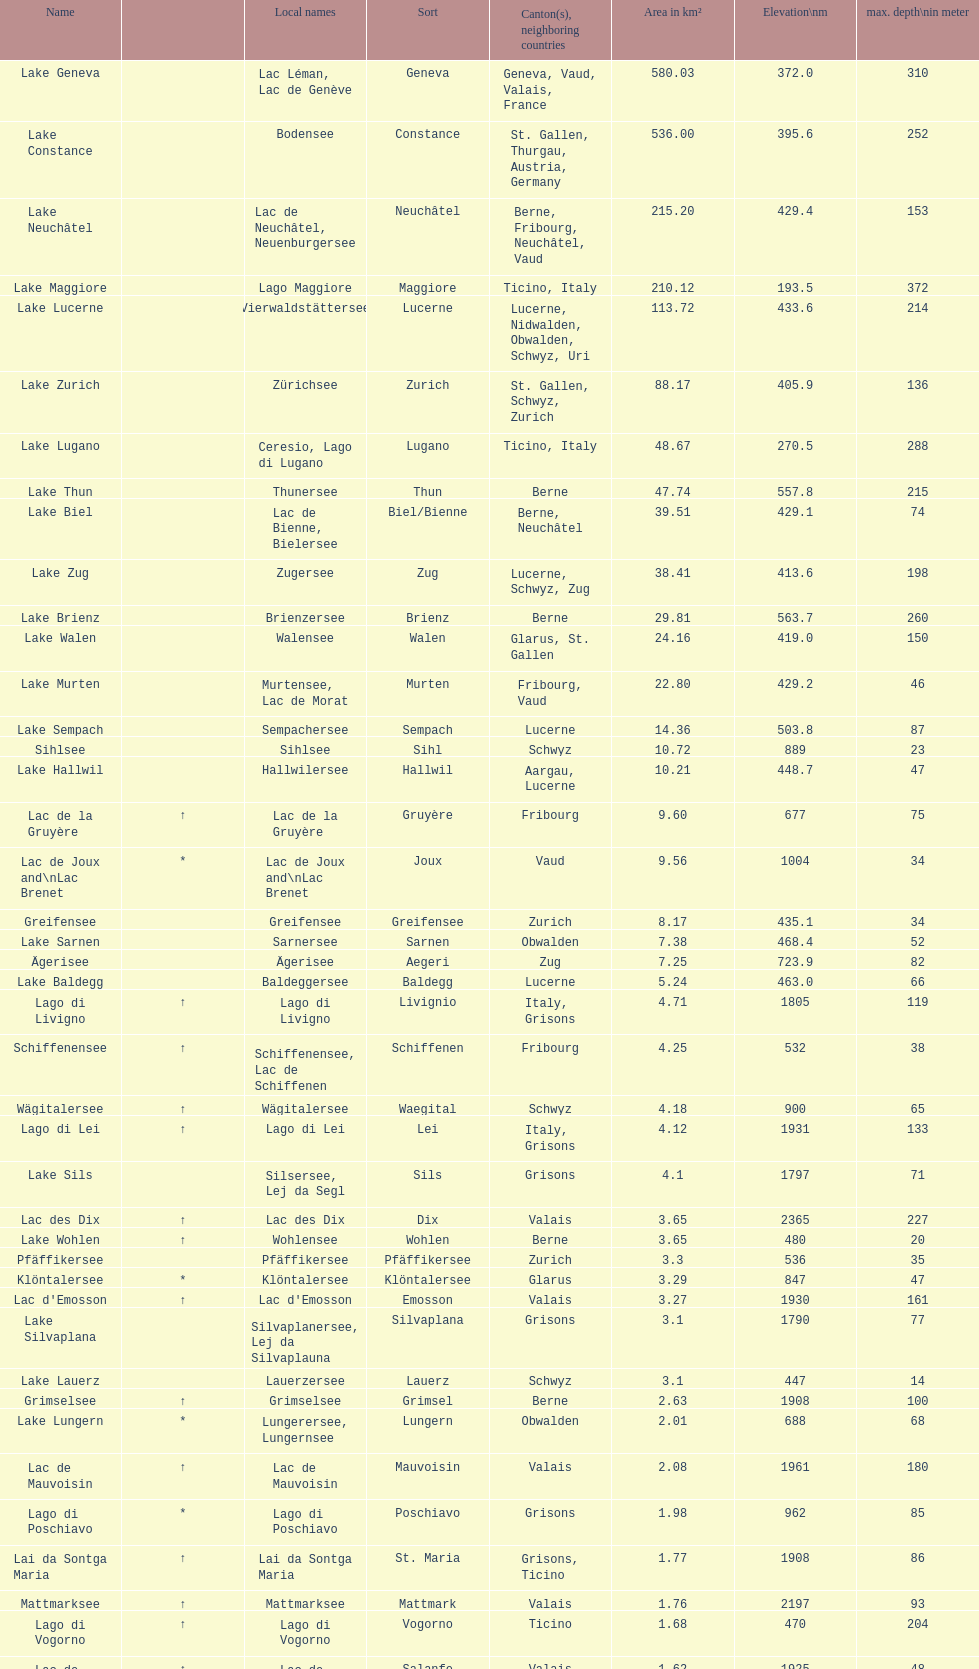Which lake is situated at the highest altitude? Lac des Dix. Can you parse all the data within this table? {'header': ['Name', '', 'Local names', 'Sort', 'Canton(s), neighboring countries', 'Area in km²', 'Elevation\\nm', 'max. depth\\nin meter'], 'rows': [['Lake Geneva', '', 'Lac Léman, Lac de Genève', 'Geneva', 'Geneva, Vaud, Valais, France', '580.03', '372.0', '310'], ['Lake Constance', '', 'Bodensee', 'Constance', 'St. Gallen, Thurgau, Austria, Germany', '536.00', '395.6', '252'], ['Lake Neuchâtel', '', 'Lac de Neuchâtel, Neuenburgersee', 'Neuchâtel', 'Berne, Fribourg, Neuchâtel, Vaud', '215.20', '429.4', '153'], ['Lake Maggiore', '', 'Lago Maggiore', 'Maggiore', 'Ticino, Italy', '210.12', '193.5', '372'], ['Lake Lucerne', '', 'Vierwaldstättersee', 'Lucerne', 'Lucerne, Nidwalden, Obwalden, Schwyz, Uri', '113.72', '433.6', '214'], ['Lake Zurich', '', 'Zürichsee', 'Zurich', 'St. Gallen, Schwyz, Zurich', '88.17', '405.9', '136'], ['Lake Lugano', '', 'Ceresio, Lago di Lugano', 'Lugano', 'Ticino, Italy', '48.67', '270.5', '288'], ['Lake Thun', '', 'Thunersee', 'Thun', 'Berne', '47.74', '557.8', '215'], ['Lake Biel', '', 'Lac de Bienne, Bielersee', 'Biel/Bienne', 'Berne, Neuchâtel', '39.51', '429.1', '74'], ['Lake Zug', '', 'Zugersee', 'Zug', 'Lucerne, Schwyz, Zug', '38.41', '413.6', '198'], ['Lake Brienz', '', 'Brienzersee', 'Brienz', 'Berne', '29.81', '563.7', '260'], ['Lake Walen', '', 'Walensee', 'Walen', 'Glarus, St. Gallen', '24.16', '419.0', '150'], ['Lake Murten', '', 'Murtensee, Lac de Morat', 'Murten', 'Fribourg, Vaud', '22.80', '429.2', '46'], ['Lake Sempach', '', 'Sempachersee', 'Sempach', 'Lucerne', '14.36', '503.8', '87'], ['Sihlsee', '', 'Sihlsee', 'Sihl', 'Schwyz', '10.72', '889', '23'], ['Lake Hallwil', '', 'Hallwilersee', 'Hallwil', 'Aargau, Lucerne', '10.21', '448.7', '47'], ['Lac de la Gruyère', '↑', 'Lac de la Gruyère', 'Gruyère', 'Fribourg', '9.60', '677', '75'], ['Lac de Joux and\\nLac Brenet', '*', 'Lac de Joux and\\nLac Brenet', 'Joux', 'Vaud', '9.56', '1004', '34'], ['Greifensee', '', 'Greifensee', 'Greifensee', 'Zurich', '8.17', '435.1', '34'], ['Lake Sarnen', '', 'Sarnersee', 'Sarnen', 'Obwalden', '7.38', '468.4', '52'], ['Ägerisee', '', 'Ägerisee', 'Aegeri', 'Zug', '7.25', '723.9', '82'], ['Lake Baldegg', '', 'Baldeggersee', 'Baldegg', 'Lucerne', '5.24', '463.0', '66'], ['Lago di Livigno', '↑', 'Lago di Livigno', 'Livignio', 'Italy, Grisons', '4.71', '1805', '119'], ['Schiffenensee', '↑', 'Schiffenensee, Lac de Schiffenen', 'Schiffenen', 'Fribourg', '4.25', '532', '38'], ['Wägitalersee', '↑', 'Wägitalersee', 'Waegital', 'Schwyz', '4.18', '900', '65'], ['Lago di Lei', '↑', 'Lago di Lei', 'Lei', 'Italy, Grisons', '4.12', '1931', '133'], ['Lake Sils', '', 'Silsersee, Lej da Segl', 'Sils', 'Grisons', '4.1', '1797', '71'], ['Lac des Dix', '↑', 'Lac des Dix', 'Dix', 'Valais', '3.65', '2365', '227'], ['Lake Wohlen', '↑', 'Wohlensee', 'Wohlen', 'Berne', '3.65', '480', '20'], ['Pfäffikersee', '', 'Pfäffikersee', 'Pfäffikersee', 'Zurich', '3.3', '536', '35'], ['Klöntalersee', '*', 'Klöntalersee', 'Klöntalersee', 'Glarus', '3.29', '847', '47'], ["Lac d'Emosson", '↑', "Lac d'Emosson", 'Emosson', 'Valais', '3.27', '1930', '161'], ['Lake Silvaplana', '', 'Silvaplanersee, Lej da Silvaplauna', 'Silvaplana', 'Grisons', '3.1', '1790', '77'], ['Lake Lauerz', '', 'Lauerzersee', 'Lauerz', 'Schwyz', '3.1', '447', '14'], ['Grimselsee', '↑', 'Grimselsee', 'Grimsel', 'Berne', '2.63', '1908', '100'], ['Lake Lungern', '*', 'Lungerersee, Lungernsee', 'Lungern', 'Obwalden', '2.01', '688', '68'], ['Lac de Mauvoisin', '↑', 'Lac de Mauvoisin', 'Mauvoisin', 'Valais', '2.08', '1961', '180'], ['Lago di Poschiavo', '*', 'Lago di Poschiavo', 'Poschiavo', 'Grisons', '1.98', '962', '85'], ['Lai da Sontga Maria', '↑', 'Lai da Sontga Maria', 'St. Maria', 'Grisons, Ticino', '1.77', '1908', '86'], ['Mattmarksee', '↑', 'Mattmarksee', 'Mattmark', 'Valais', '1.76', '2197', '93'], ['Lago di Vogorno', '↑', 'Lago di Vogorno', 'Vogorno', 'Ticino', '1.68', '470', '204'], ['Lac de Salanfe', '↑', 'Lac de Salanfe', 'Salanfe', 'Valais', '1.62', '1925', '48'], ['Zervreilasee', '↑', 'Zervreilasee', 'Zervreila', 'Grisons', '1.61', '1862', '140'], ["Lac de l'Hongrin", '↑', "Lac de l'Hongrin", 'Hongrin', 'Vaud', '1.60', '1255', '105'], ['Lago Bianco', '*', 'Lago Bianco', 'Bianco', 'Grisons', '1.50', '2234', '53'], ['Lago Ritom', '*', 'Lago Ritom', 'Ritom', 'Ticino', '1.49', '1850', '69'], ['Oberaarsee', '↑', 'Oberaarsee', 'Oberaar', 'Berne', '1.47', '2303', '90'], ['Lai da Marmorera', '↑', 'Lai da Marmorera', 'Marmorera', 'Grisons', '1.41', '1680', '65'], ['Lac de Moiry', '↑', 'Lac de Moiry', 'Moiry', 'Valais', '1.40', '2249', '120'], ['Limmernsee', '↑', 'Limmernsee', 'Limmern', 'Glarus', '1.36', '1857', '122'], ['Göscheneralpsee', '↑', 'Göscheneralpsee', 'Göscheneralp', 'Uri', '1.32', '1792', '106'], ['Lago di Luzzone', '↑', 'Lago di Luzzone', 'Luzzone', 'Ticino', '1.27', '1606', '181'], ['Klingnauer Stausee', '↑', 'Klingnauer Stausee', 'Klingnau', 'Aargau', '1.16', '318', '8.5'], ['Albigna lake', '↑', "Lago da l'Albigna\\nLägh da l'Albigna", 'Albigna', 'Grisons', '1.13', '2163', '108'], ['Oeschinen Lake', '↑', 'Oeschinensee', 'Oeschinen', 'Berne', '1.11', '1578', '56'], ['Lago del Sambuco', '↑', 'Lago del Sambuco', 'Sambuco', 'Ticino', '1.11', '1461', '124']]} 